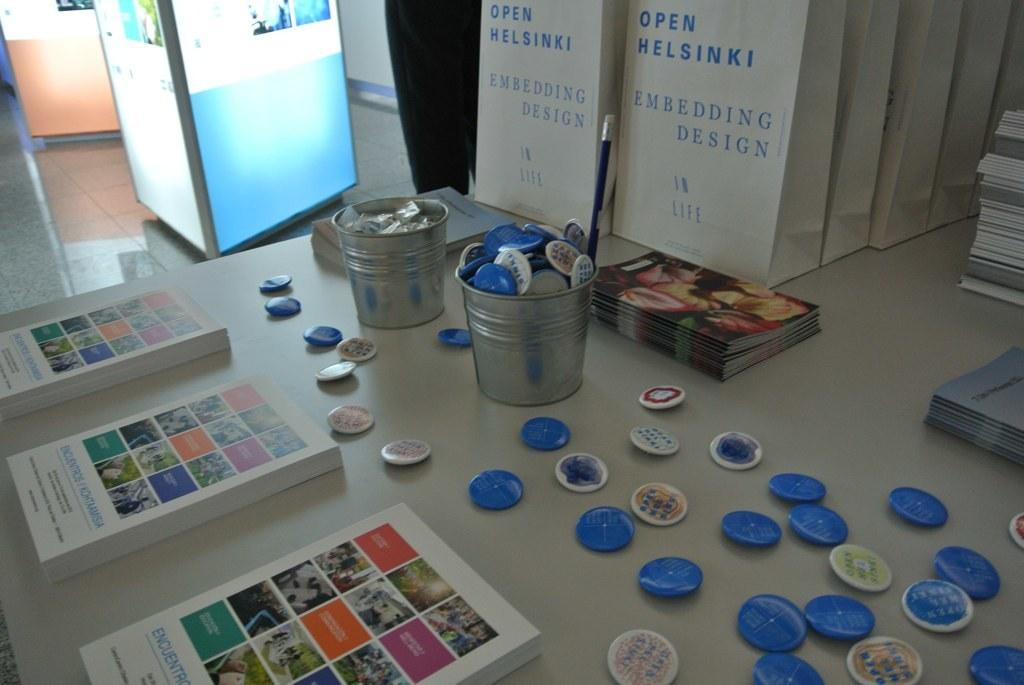<image>
Give a short and clear explanation of the subsequent image. Open Helsinki white bags with buttons and brochures on the table. 